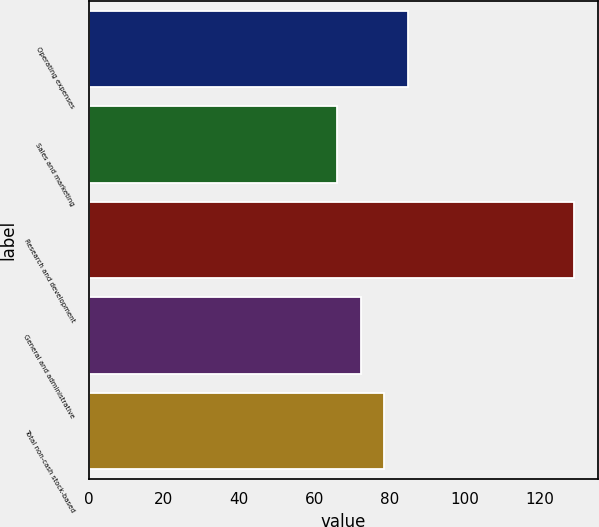Convert chart to OTSL. <chart><loc_0><loc_0><loc_500><loc_500><bar_chart><fcel>Operating expenses<fcel>Sales and marketing<fcel>Research and development<fcel>General and administrative<fcel>Total non-cash stock-based<nl><fcel>84.9<fcel>66<fcel>129<fcel>72.3<fcel>78.6<nl></chart> 